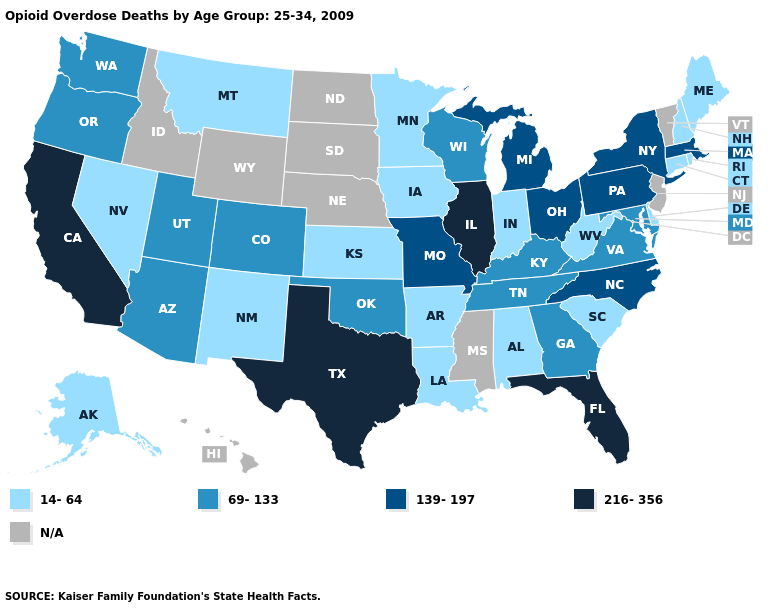Name the states that have a value in the range 216-356?
Short answer required. California, Florida, Illinois, Texas. What is the highest value in the USA?
Give a very brief answer. 216-356. What is the value of Colorado?
Give a very brief answer. 69-133. How many symbols are there in the legend?
Short answer required. 5. What is the lowest value in the West?
Write a very short answer. 14-64. Among the states that border Kentucky , does West Virginia have the lowest value?
Answer briefly. Yes. Which states have the lowest value in the Northeast?
Be succinct. Connecticut, Maine, New Hampshire, Rhode Island. Name the states that have a value in the range 216-356?
Give a very brief answer. California, Florida, Illinois, Texas. Does Michigan have the lowest value in the USA?
Answer briefly. No. What is the lowest value in states that border Oklahoma?
Short answer required. 14-64. What is the highest value in states that border Oklahoma?
Short answer required. 216-356. Name the states that have a value in the range 14-64?
Keep it brief. Alabama, Alaska, Arkansas, Connecticut, Delaware, Indiana, Iowa, Kansas, Louisiana, Maine, Minnesota, Montana, Nevada, New Hampshire, New Mexico, Rhode Island, South Carolina, West Virginia. What is the value of Vermont?
Be succinct. N/A. Among the states that border Mississippi , which have the highest value?
Write a very short answer. Tennessee. 